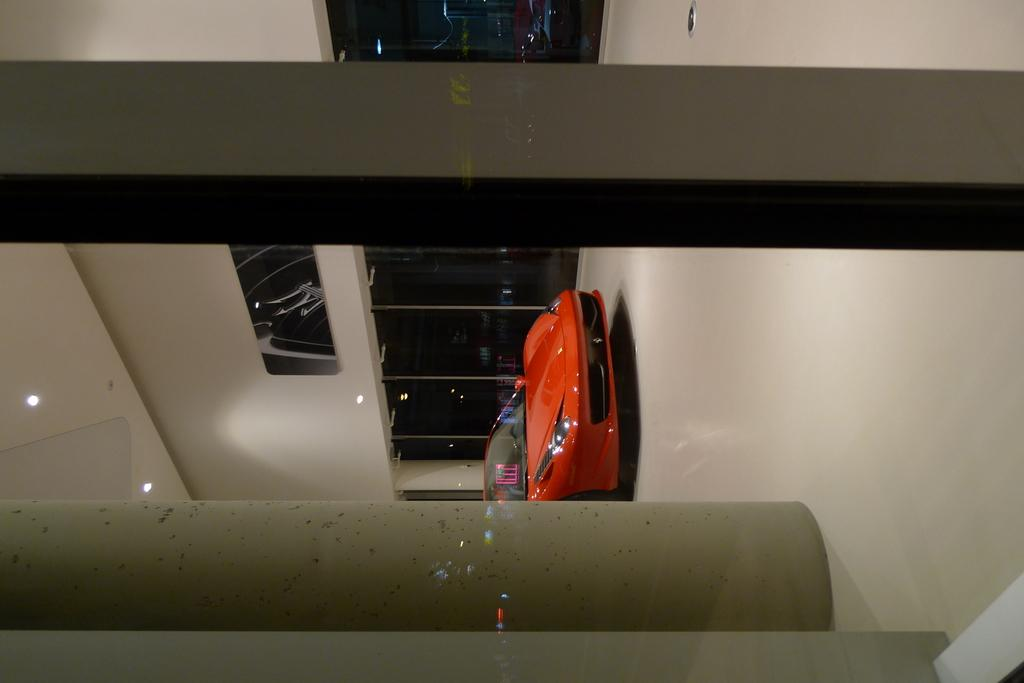What type of vehicle is in the image? There is a red car in the image. Where is the car located? The car is in a showroom. What can be seen on the sides of the showroom? There are glass doors in the image. What architectural features are present in the showroom? There are pillars in the image. What is the source of light in the image? There is light visible in the image. What is the background of the car in the image? There is a wall in the image. What type of song is being played by the toad in the image? There is no toad or song present in the image. 